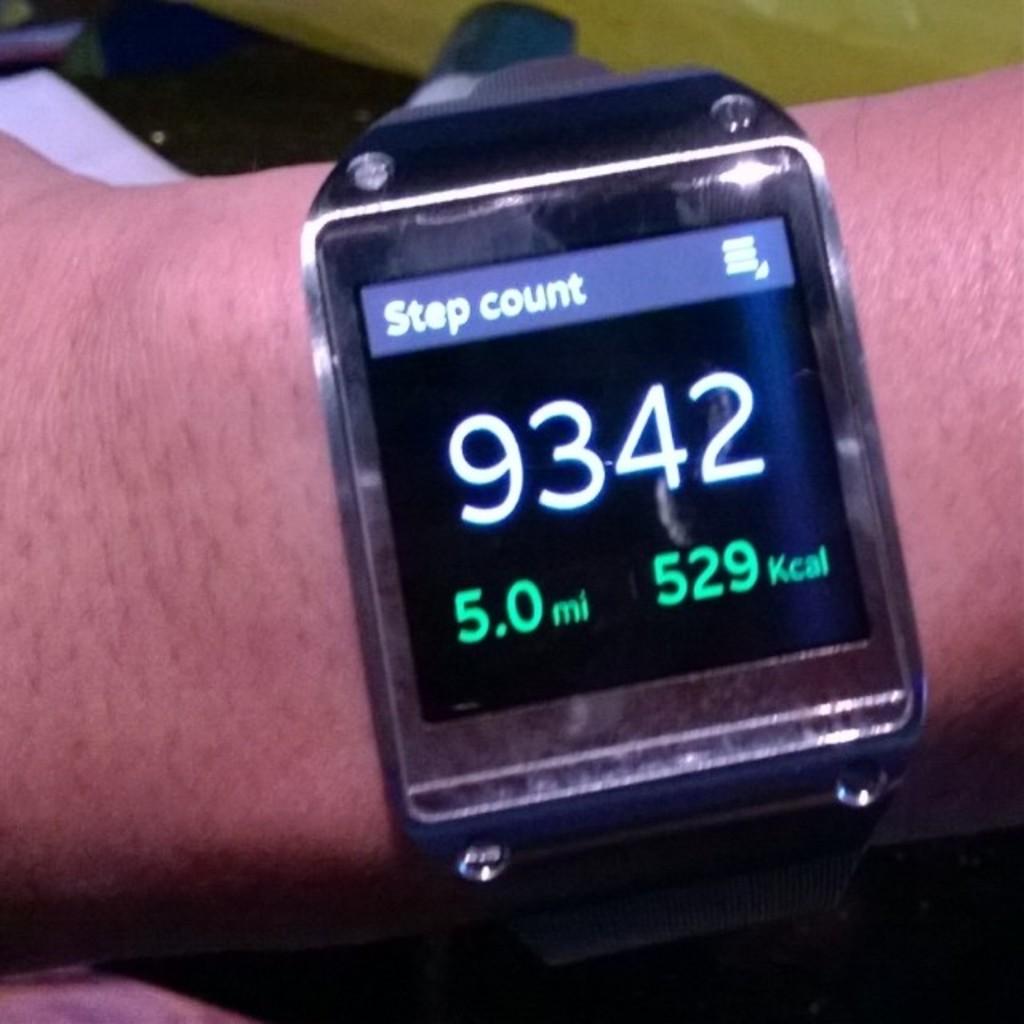How many miles has this person walked?
Your response must be concise. 5.0. What is the watch counting?
Ensure brevity in your answer.  Step. 